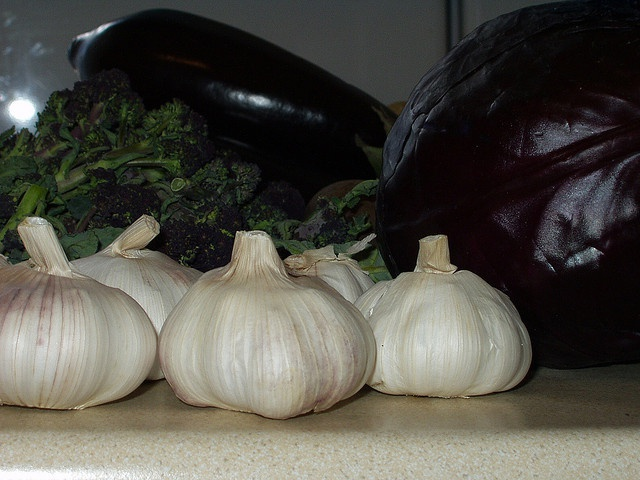Describe the objects in this image and their specific colors. I can see broccoli in black, darkgreen, and gray tones, broccoli in black, purple, and darkgreen tones, broccoli in black, darkgreen, and gray tones, broccoli in black, darkgreen, and gray tones, and broccoli in black, darkgreen, and gray tones in this image. 